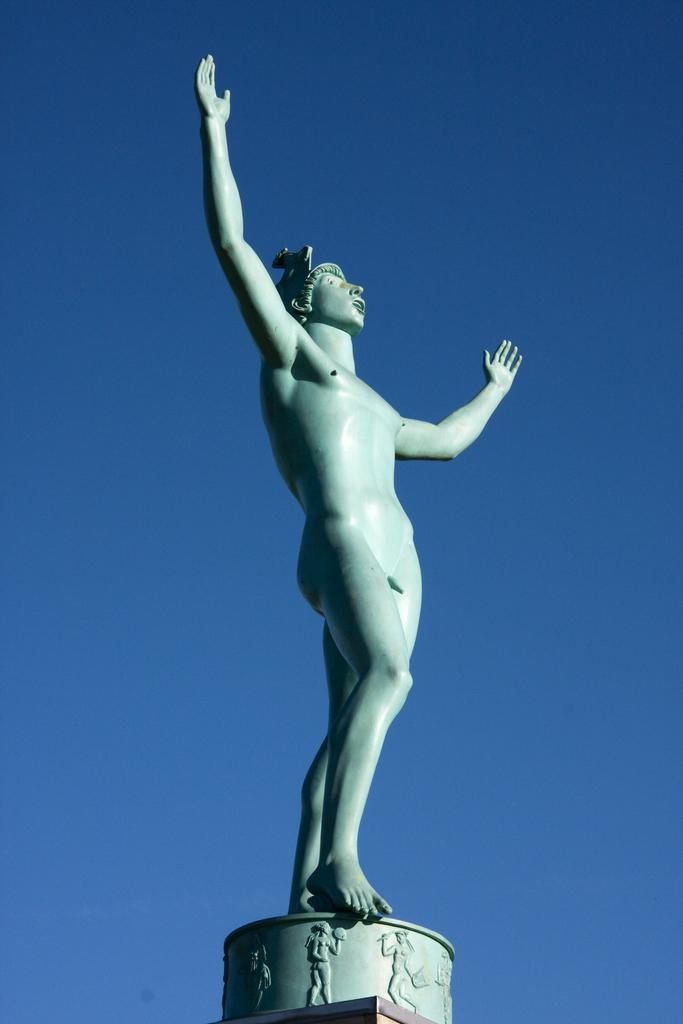What is the main subject of the image? There is a statue of a person in the image. Where is the statue located? The statue is on a platform. What can be seen in the background of the image? The sky is visible in the background of the image. What type of shop can be seen near the statue in the image? There is no shop present in the image; it only features a statue of a person on a platform with the sky visible in the background. 